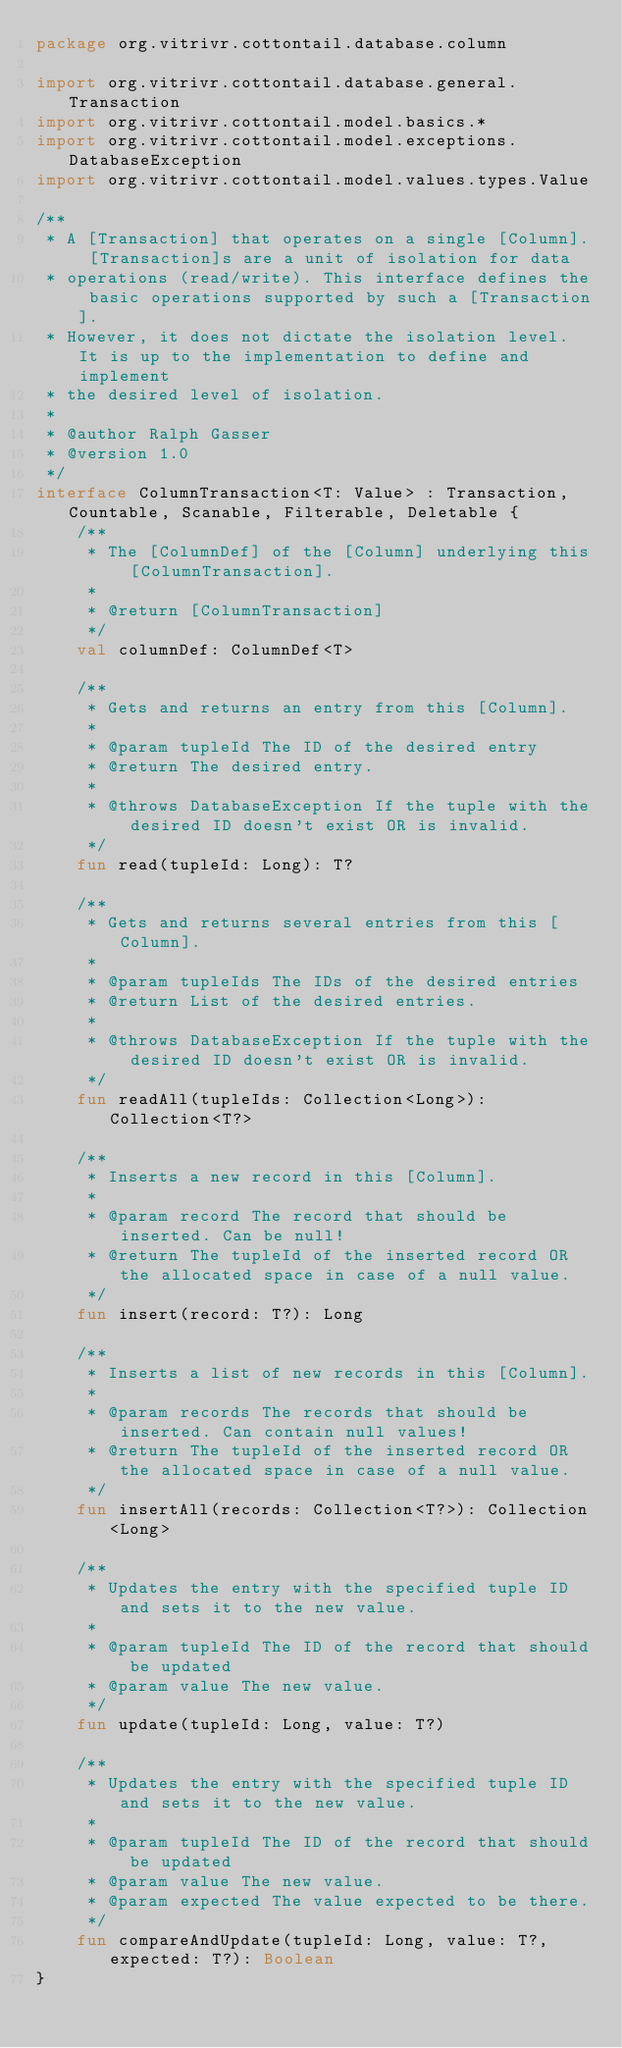<code> <loc_0><loc_0><loc_500><loc_500><_Kotlin_>package org.vitrivr.cottontail.database.column

import org.vitrivr.cottontail.database.general.Transaction
import org.vitrivr.cottontail.model.basics.*
import org.vitrivr.cottontail.model.exceptions.DatabaseException
import org.vitrivr.cottontail.model.values.types.Value

/**
 * A [Transaction] that operates on a single [Column]. [Transaction]s are a unit of isolation for data
 * operations (read/write). This interface defines the basic operations supported by such a [Transaction].
 * However, it does not dictate the isolation level. It is up to the implementation to define and implement
 * the desired level of isolation.
 *
 * @author Ralph Gasser
 * @version 1.0
 */
interface ColumnTransaction<T: Value> : Transaction, Countable, Scanable, Filterable, Deletable {
    /**
     * The [ColumnDef] of the [Column] underlying this [ColumnTransaction].
     *
     * @return [ColumnTransaction]
     */
    val columnDef: ColumnDef<T>

    /**
     * Gets and returns an entry from this [Column].
     *
     * @param tupleId The ID of the desired entry
     * @return The desired entry.
     *
     * @throws DatabaseException If the tuple with the desired ID doesn't exist OR is invalid.
     */
    fun read(tupleId: Long): T?

    /**
     * Gets and returns several entries from this [Column].
     *
     * @param tupleIds The IDs of the desired entries
     * @return List of the desired entries.
     *
     * @throws DatabaseException If the tuple with the desired ID doesn't exist OR is invalid.
     */
    fun readAll(tupleIds: Collection<Long>): Collection<T?>

    /**
     * Inserts a new record in this [Column].
     *
     * @param record The record that should be inserted. Can be null!
     * @return The tupleId of the inserted record OR the allocated space in case of a null value.
     */
    fun insert(record: T?): Long

    /**
     * Inserts a list of new records in this [Column].
     *
     * @param records The records that should be inserted. Can contain null values!
     * @return The tupleId of the inserted record OR the allocated space in case of a null value.
     */
    fun insertAll(records: Collection<T?>): Collection<Long>

    /**
     * Updates the entry with the specified tuple ID and sets it to the new value.
     *
     * @param tupleId The ID of the record that should be updated
     * @param value The new value.
     */
    fun update(tupleId: Long, value: T?)

    /**
     * Updates the entry with the specified tuple ID and sets it to the new value.
     *
     * @param tupleId The ID of the record that should be updated
     * @param value The new value.
     * @param expected The value expected to be there.
     */
    fun compareAndUpdate(tupleId: Long, value: T?, expected: T?): Boolean
}</code> 